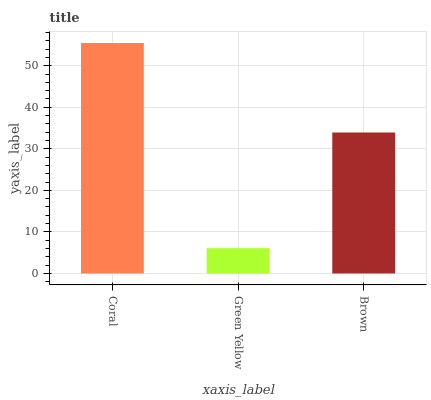Is Brown the minimum?
Answer yes or no. No. Is Brown the maximum?
Answer yes or no. No. Is Brown greater than Green Yellow?
Answer yes or no. Yes. Is Green Yellow less than Brown?
Answer yes or no. Yes. Is Green Yellow greater than Brown?
Answer yes or no. No. Is Brown less than Green Yellow?
Answer yes or no. No. Is Brown the high median?
Answer yes or no. Yes. Is Brown the low median?
Answer yes or no. Yes. Is Coral the high median?
Answer yes or no. No. Is Coral the low median?
Answer yes or no. No. 